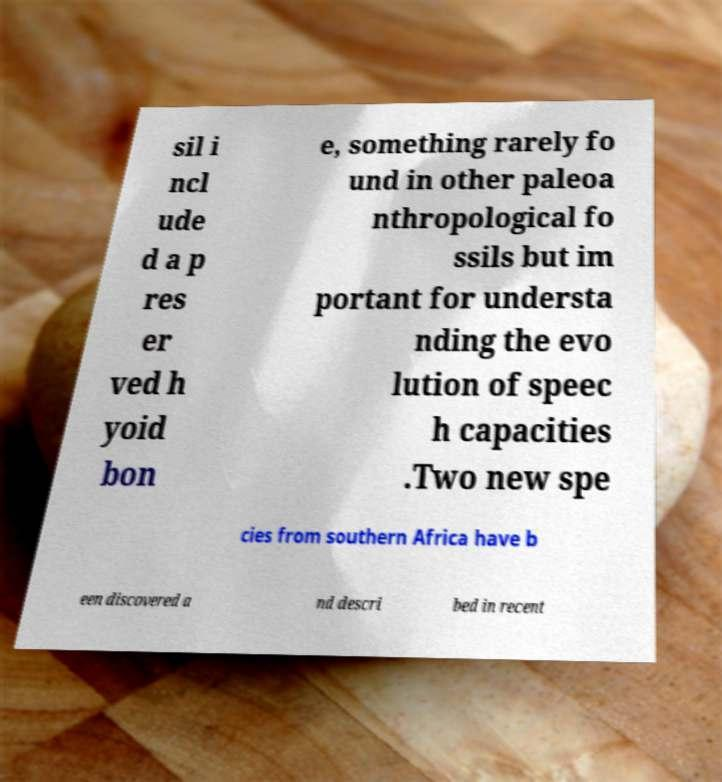I need the written content from this picture converted into text. Can you do that? sil i ncl ude d a p res er ved h yoid bon e, something rarely fo und in other paleoa nthropological fo ssils but im portant for understa nding the evo lution of speec h capacities .Two new spe cies from southern Africa have b een discovered a nd descri bed in recent 